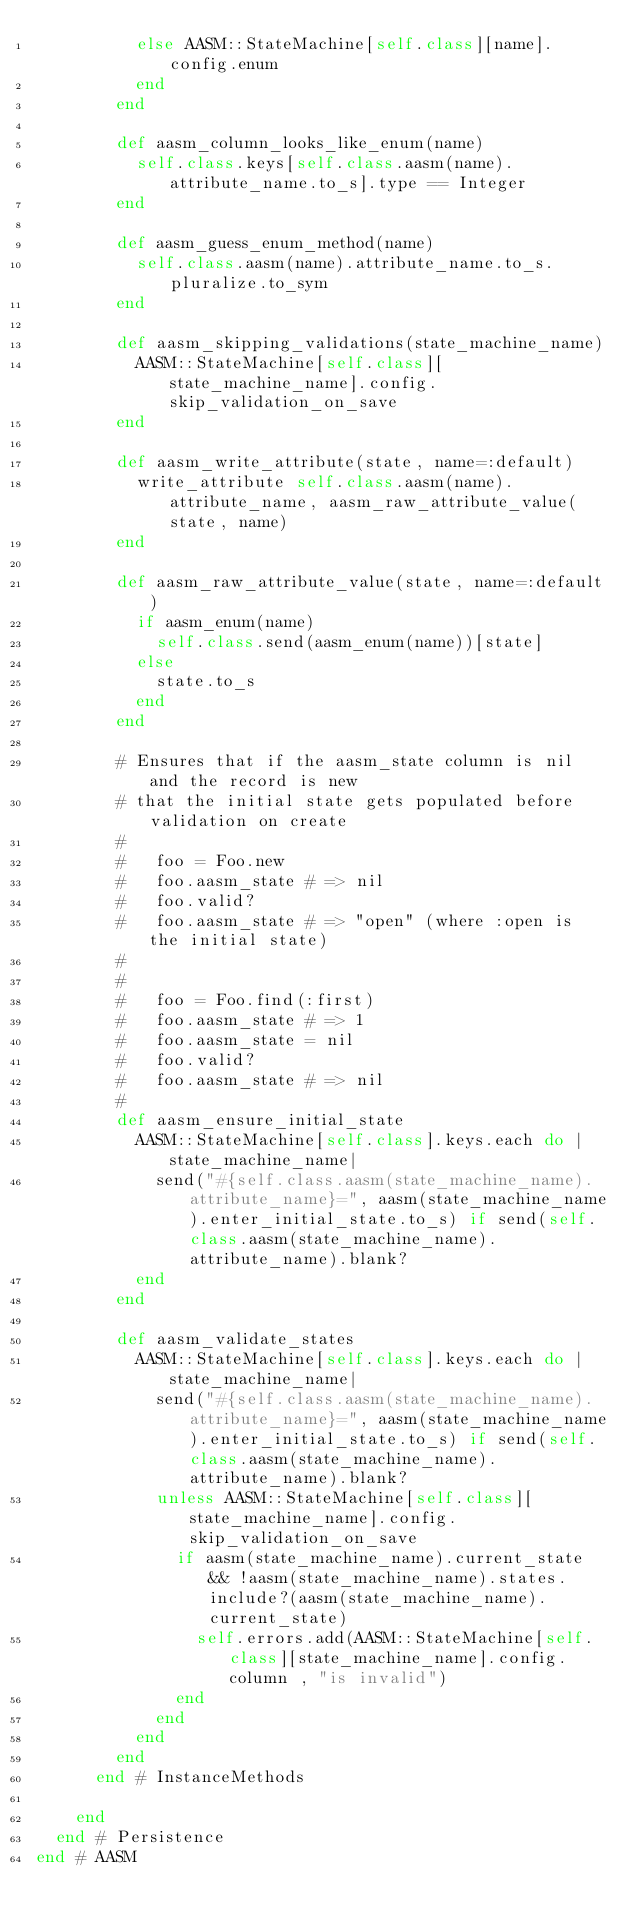Convert code to text. <code><loc_0><loc_0><loc_500><loc_500><_Ruby_>          else AASM::StateMachine[self.class][name].config.enum
          end
        end

        def aasm_column_looks_like_enum(name)
          self.class.keys[self.class.aasm(name).attribute_name.to_s].type == Integer
        end

        def aasm_guess_enum_method(name)
          self.class.aasm(name).attribute_name.to_s.pluralize.to_sym
        end

        def aasm_skipping_validations(state_machine_name)
          AASM::StateMachine[self.class][state_machine_name].config.skip_validation_on_save
        end

        def aasm_write_attribute(state, name=:default)
          write_attribute self.class.aasm(name).attribute_name, aasm_raw_attribute_value(state, name)
        end

        def aasm_raw_attribute_value(state, name=:default)
          if aasm_enum(name)
            self.class.send(aasm_enum(name))[state]
          else
            state.to_s
          end
        end

        # Ensures that if the aasm_state column is nil and the record is new
        # that the initial state gets populated before validation on create
        #
        #   foo = Foo.new
        #   foo.aasm_state # => nil
        #   foo.valid?
        #   foo.aasm_state # => "open" (where :open is the initial state)
        #
        #
        #   foo = Foo.find(:first)
        #   foo.aasm_state # => 1
        #   foo.aasm_state = nil
        #   foo.valid?
        #   foo.aasm_state # => nil
        #
        def aasm_ensure_initial_state
          AASM::StateMachine[self.class].keys.each do |state_machine_name|
            send("#{self.class.aasm(state_machine_name).attribute_name}=", aasm(state_machine_name).enter_initial_state.to_s) if send(self.class.aasm(state_machine_name).attribute_name).blank?
          end
        end

        def aasm_validate_states
          AASM::StateMachine[self.class].keys.each do |state_machine_name|
            send("#{self.class.aasm(state_machine_name).attribute_name}=", aasm(state_machine_name).enter_initial_state.to_s) if send(self.class.aasm(state_machine_name).attribute_name).blank?
            unless AASM::StateMachine[self.class][state_machine_name].config.skip_validation_on_save
              if aasm(state_machine_name).current_state && !aasm(state_machine_name).states.include?(aasm(state_machine_name).current_state)
                self.errors.add(AASM::StateMachine[self.class][state_machine_name].config.column , "is invalid")
              end
            end
          end
        end
      end # InstanceMethods

    end
  end # Persistence
end # AASM
</code> 